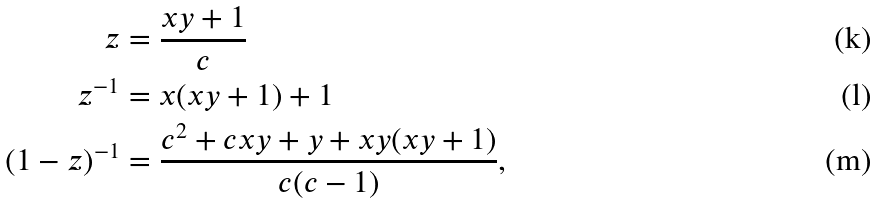Convert formula to latex. <formula><loc_0><loc_0><loc_500><loc_500>z & = \frac { x y + 1 } { c } \\ z ^ { - 1 } & = x ( x y + 1 ) + 1 \\ ( 1 - z ) ^ { - 1 } & = \frac { c ^ { 2 } + c x y + y + x y ( x y + 1 ) } { c ( c - 1 ) } ,</formula> 